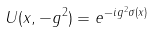<formula> <loc_0><loc_0><loc_500><loc_500>U ( x , - g ^ { 2 } ) = e ^ { - i g ^ { 2 } \sigma ( x ) }</formula> 